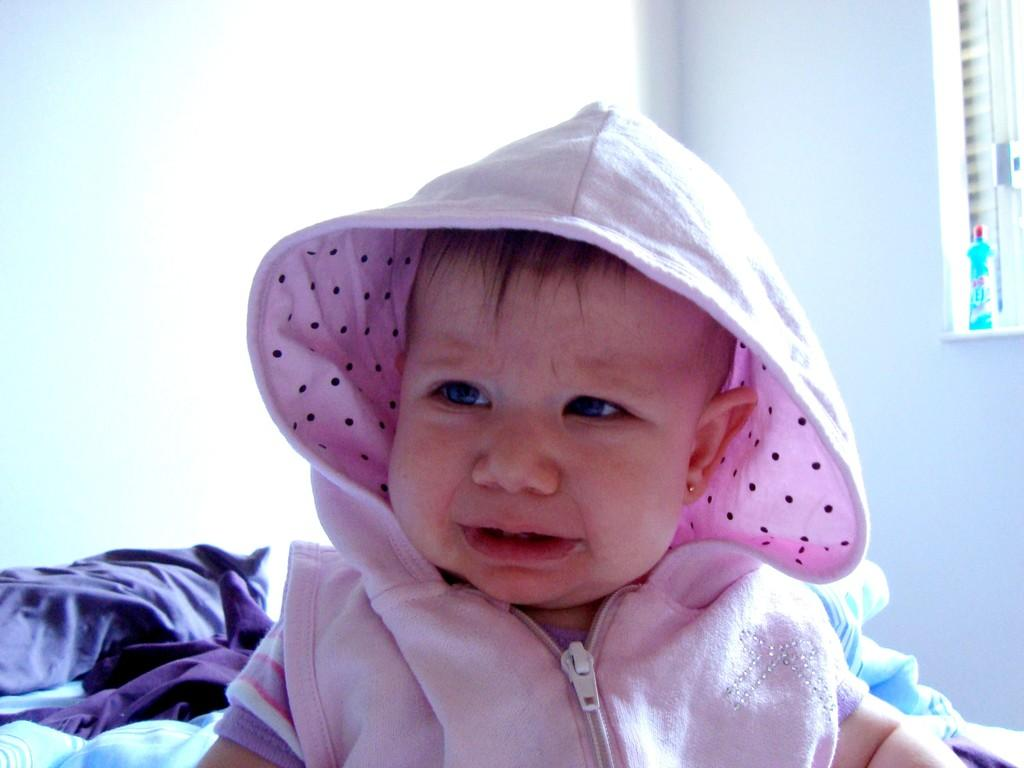What is the main subject of the picture? The main subject of the picture is a baby. What is the baby doing in the picture? The baby is crying in the picture. What is the baby wearing in the picture? The baby is wearing a pink dress in the picture. What type of vegetable is the baby holding in the picture? There is no vegetable present in the image; the baby is not holding anything. 